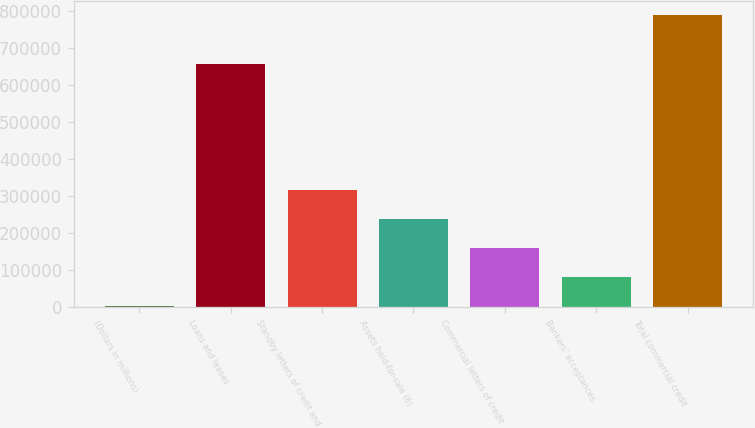Convert chart to OTSL. <chart><loc_0><loc_0><loc_500><loc_500><bar_chart><fcel>(Dollars in millions)<fcel>Loans and leases<fcel>Standby letters of credit and<fcel>Assets held-for-sale (6)<fcel>Commercial letters of credit<fcel>Bankers' acceptances<fcel>Total commercial credit<nl><fcel>2007<fcel>654539<fcel>316321<fcel>237742<fcel>159164<fcel>80585.5<fcel>787792<nl></chart> 